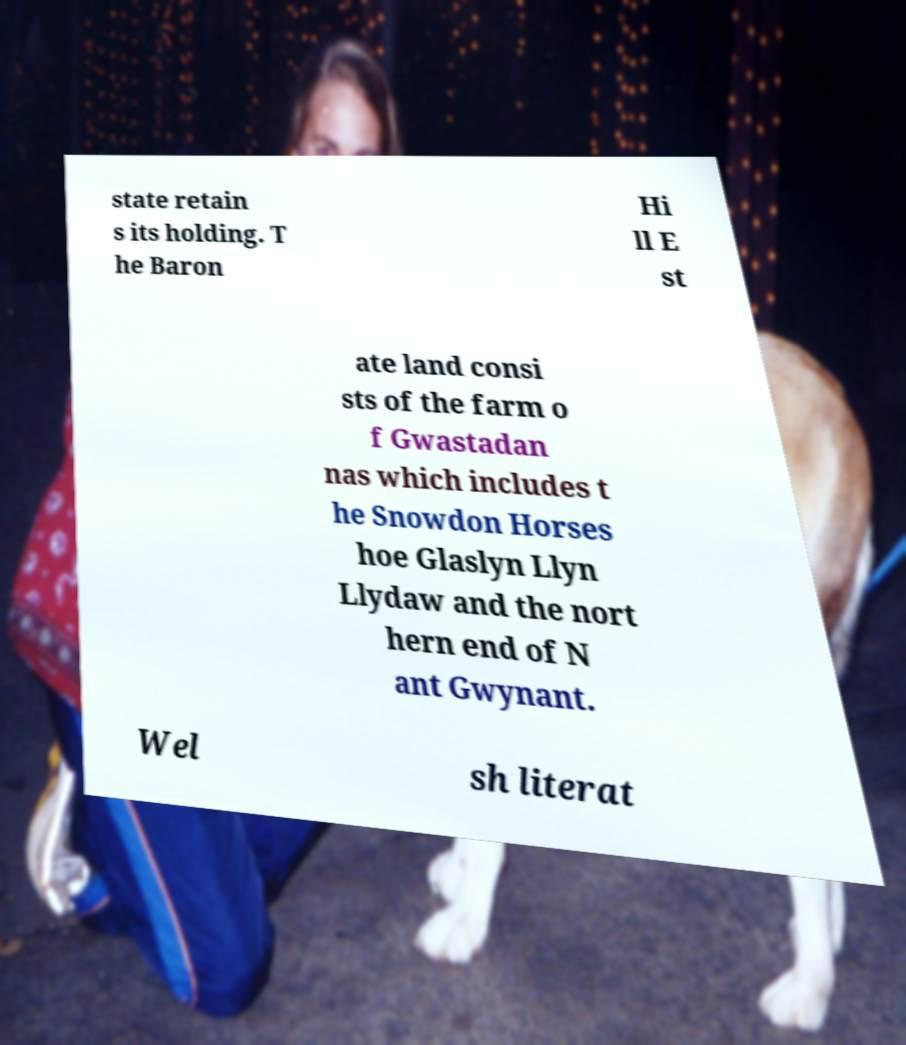Please read and relay the text visible in this image. What does it say? state retain s its holding. T he Baron Hi ll E st ate land consi sts of the farm o f Gwastadan nas which includes t he Snowdon Horses hoe Glaslyn Llyn Llydaw and the nort hern end of N ant Gwynant. Wel sh literat 